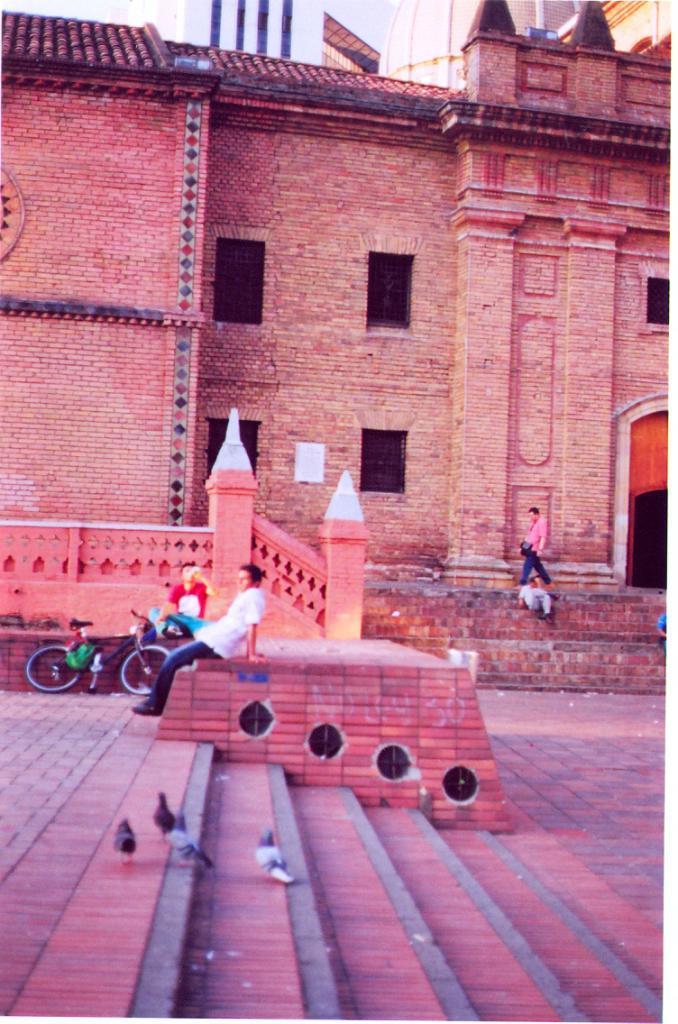Could you give a brief overview of what you see in this image? In this image we can see steps. On the steps there are birds. Near to the steps there is a wall. On that a person is sitting. In the back there is a building with windows. Near to that there are steps. And a person is sitting on the steps and a person is walking. On the left side there is a cycle. Near to that a person is sitting. 